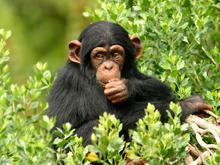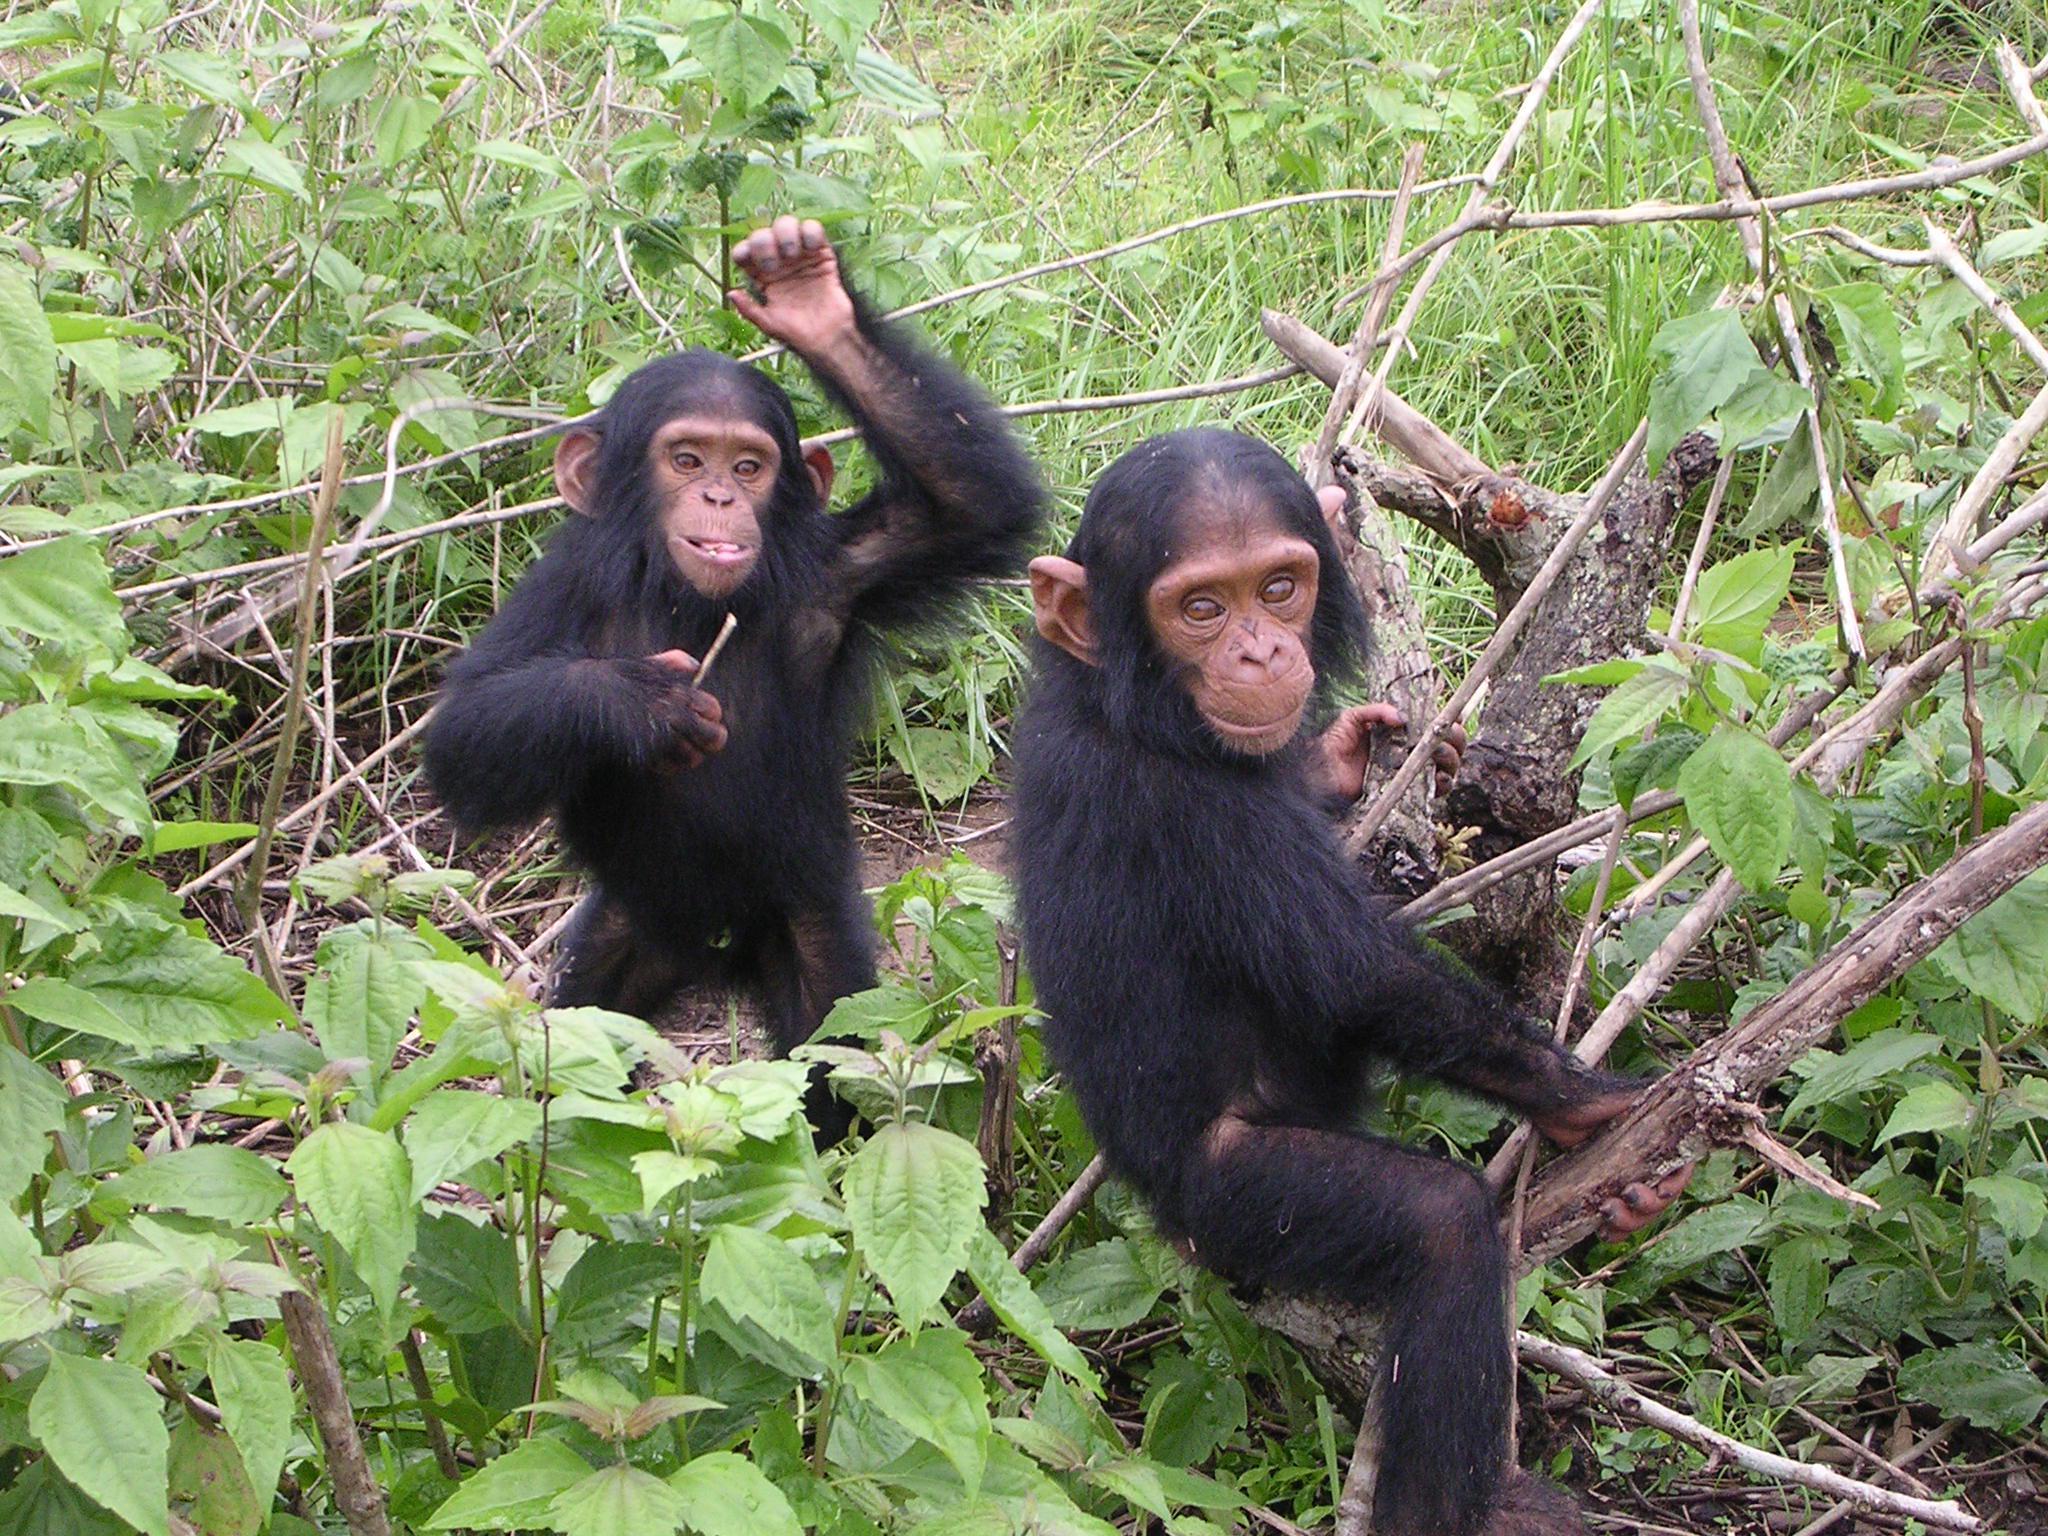The first image is the image on the left, the second image is the image on the right. For the images shown, is this caption "An image shows exactly one chimp, in a squatting position with forearms on knees." true? Answer yes or no. No. 